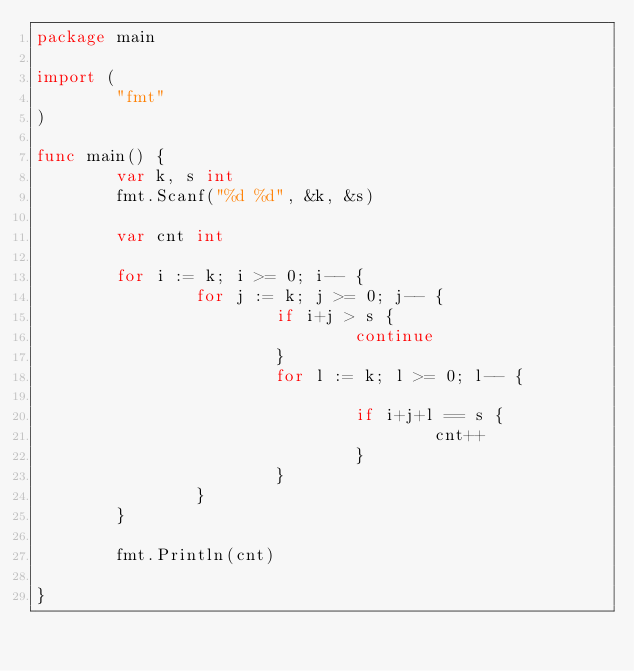<code> <loc_0><loc_0><loc_500><loc_500><_Go_>package main

import (
        "fmt"
)

func main() {
        var k, s int
        fmt.Scanf("%d %d", &k, &s)

        var cnt int

        for i := k; i >= 0; i-- {
                for j := k; j >= 0; j-- {
                        if i+j > s {
                                continue
                        }
                        for l := k; l >= 0; l-- {

                                if i+j+l == s {
                                        cnt++
                                }
                        }
                }
        }

        fmt.Println(cnt)

}
</code> 